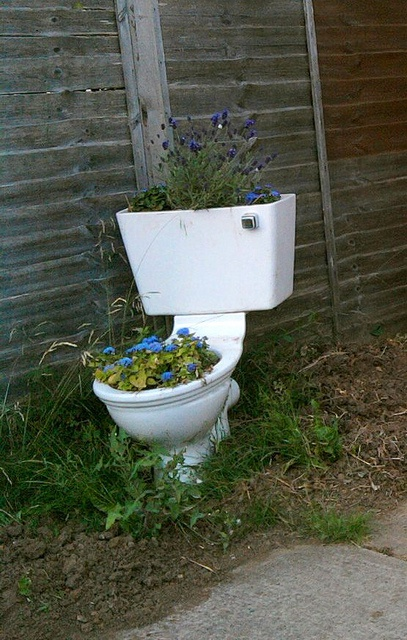Describe the objects in this image and their specific colors. I can see toilet in purple, lavender, darkgray, gray, and lightblue tones and potted plant in purple, gray, black, and darkgreen tones in this image. 